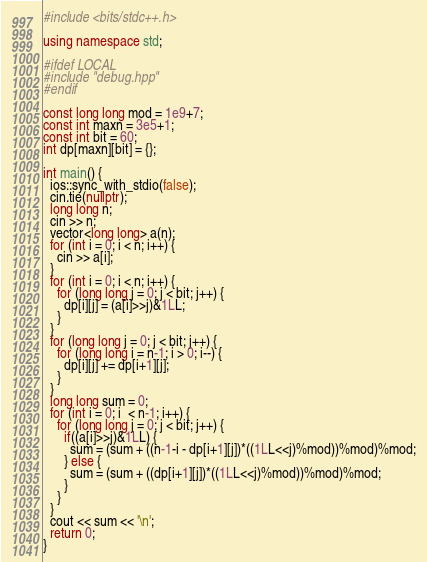Convert code to text. <code><loc_0><loc_0><loc_500><loc_500><_C++_>#include <bits/stdc++.h>
 
using namespace std;

#ifdef LOCAL
#include "debug.hpp"
#endif
 
const long long mod = 1e9+7;
const int maxn = 3e5+1;
const int bit = 60;
int dp[maxn][bit] = {};

int main() {
  ios::sync_with_stdio(false);
  cin.tie(nullptr);
  long long n;
  cin >> n;
  vector<long long> a(n);
  for (int i = 0; i < n; i++) {
    cin >> a[i];
  } 
  for (int i = 0; i < n; i++) {
    for (long long j = 0; j < bit; j++) {
      dp[i][j] = (a[i]>>j)&1LL;
    }
  } 
  for (long long j = 0; j < bit; j++) {
    for (long long i = n-1; i > 0; i--) {
      dp[i][j] += dp[i+1][j];
    }
  }
  long long sum = 0;
  for (int i = 0; i  < n-1; i++) {
    for (long long j = 0; j < bit; j++) {
      if((a[i]>>j)&1LL) {
        sum = (sum + ((n-1-i - dp[i+1][j])*((1LL<<j)%mod))%mod)%mod;
      } else {
        sum = (sum + ((dp[i+1][j])*((1LL<<j)%mod))%mod)%mod;
      }
    }
  }  
  cout << sum << '\n';
  return 0;
}
</code> 